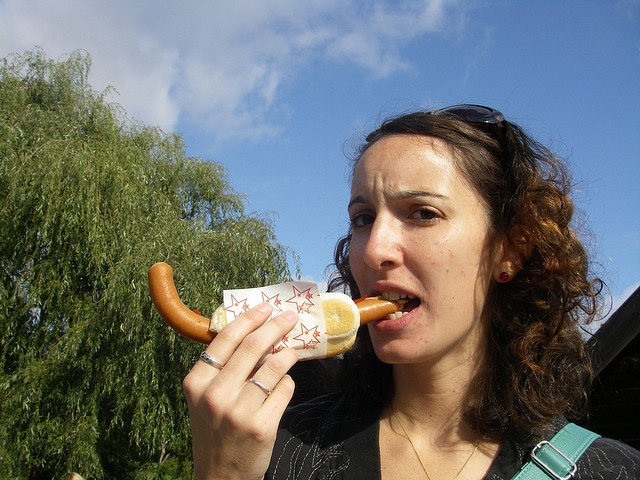Describe the objects in this image and their specific colors. I can see people in darkgray, black, maroon, and tan tones, hot dog in darkgray, ivory, tan, and brown tones, and handbag in darkgray, turquoise, black, lightblue, and teal tones in this image. 